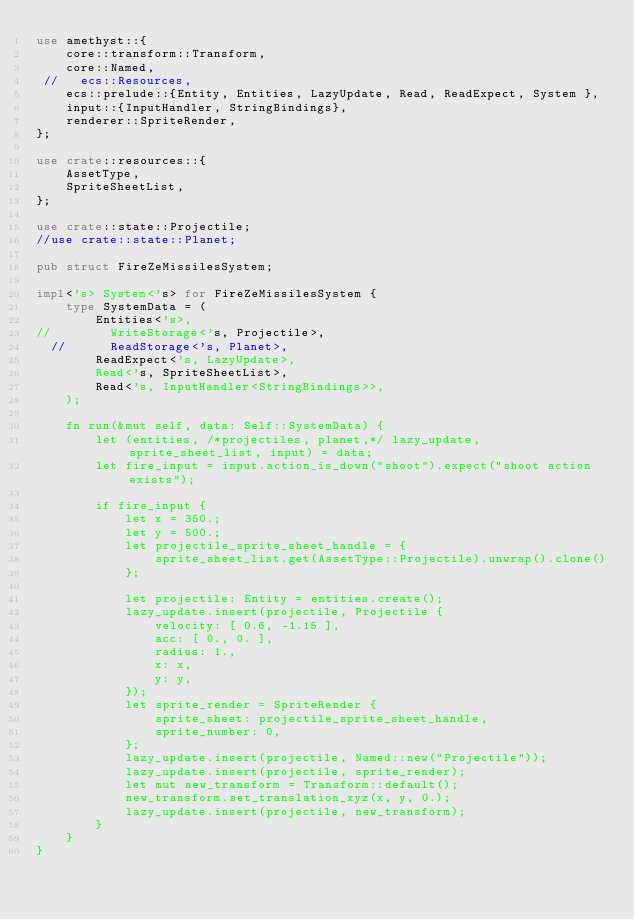Convert code to text. <code><loc_0><loc_0><loc_500><loc_500><_Rust_>use amethyst::{
    core::transform::Transform,
    core::Named,
 //   ecs::Resources,
    ecs::prelude::{Entity, Entities, LazyUpdate, Read, ReadExpect, System },
    input::{InputHandler, StringBindings},
    renderer::SpriteRender,
};

use crate::resources::{
    AssetType,
    SpriteSheetList,
};

use crate::state::Projectile;
//use crate::state::Planet;

pub struct FireZeMissilesSystem;

impl<'s> System<'s> for FireZeMissilesSystem {
    type SystemData = (
        Entities<'s>,
//        WriteStorage<'s, Projectile>,
  //      ReadStorage<'s, Planet>,
        ReadExpect<'s, LazyUpdate>,
        Read<'s, SpriteSheetList>,
        Read<'s, InputHandler<StringBindings>>,
    );

    fn run(&mut self, data: Self::SystemData) {
        let (entities, /*projectiles, planet,*/ lazy_update, sprite_sheet_list, input) = data;
        let fire_input = input.action_is_down("shoot").expect("shoot action exists");

        if fire_input {
            let x = 350.;
            let y = 500.;
            let projectile_sprite_sheet_handle = {
                sprite_sheet_list.get(AssetType::Projectile).unwrap().clone()
            };

            let projectile: Entity = entities.create();
            lazy_update.insert(projectile, Projectile {
                velocity: [ 0.6, -1.15 ],
                acc: [ 0., 0. ],
                radius: 1.,
                x: x,
                y: y,
            });
            let sprite_render = SpriteRender {
                sprite_sheet: projectile_sprite_sheet_handle,
                sprite_number: 0,
            };
            lazy_update.insert(projectile, Named::new("Projectile"));
            lazy_update.insert(projectile, sprite_render);
            let mut new_transform = Transform::default();
            new_transform.set_translation_xyz(x, y, 0.);
            lazy_update.insert(projectile, new_transform);
        }
    }
}
</code> 